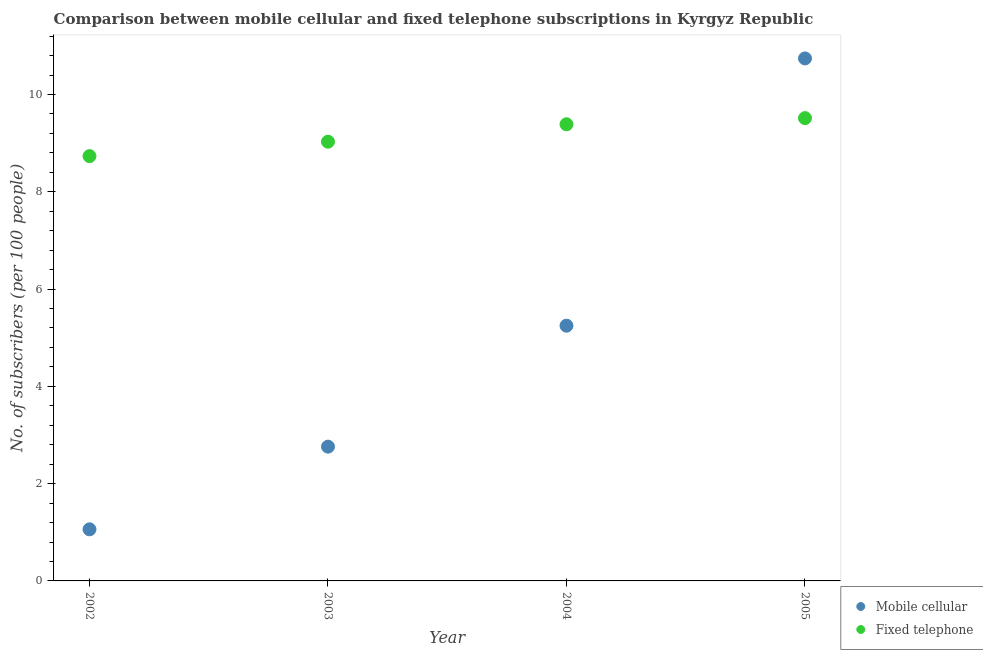Is the number of dotlines equal to the number of legend labels?
Ensure brevity in your answer.  Yes. What is the number of mobile cellular subscribers in 2002?
Offer a terse response. 1.06. Across all years, what is the maximum number of fixed telephone subscribers?
Give a very brief answer. 9.51. Across all years, what is the minimum number of mobile cellular subscribers?
Your response must be concise. 1.06. In which year was the number of fixed telephone subscribers maximum?
Offer a terse response. 2005. What is the total number of mobile cellular subscribers in the graph?
Make the answer very short. 19.81. What is the difference between the number of fixed telephone subscribers in 2002 and that in 2005?
Offer a very short reply. -0.78. What is the difference between the number of fixed telephone subscribers in 2003 and the number of mobile cellular subscribers in 2004?
Your answer should be very brief. 3.78. What is the average number of fixed telephone subscribers per year?
Offer a very short reply. 9.17. In the year 2003, what is the difference between the number of mobile cellular subscribers and number of fixed telephone subscribers?
Your response must be concise. -6.27. What is the ratio of the number of fixed telephone subscribers in 2002 to that in 2003?
Ensure brevity in your answer.  0.97. What is the difference between the highest and the second highest number of fixed telephone subscribers?
Keep it short and to the point. 0.13. What is the difference between the highest and the lowest number of fixed telephone subscribers?
Ensure brevity in your answer.  0.78. In how many years, is the number of mobile cellular subscribers greater than the average number of mobile cellular subscribers taken over all years?
Provide a short and direct response. 2. Is the number of mobile cellular subscribers strictly less than the number of fixed telephone subscribers over the years?
Offer a terse response. No. How many dotlines are there?
Your answer should be compact. 2. How many years are there in the graph?
Make the answer very short. 4. Are the values on the major ticks of Y-axis written in scientific E-notation?
Ensure brevity in your answer.  No. Does the graph contain any zero values?
Provide a short and direct response. No. How are the legend labels stacked?
Ensure brevity in your answer.  Vertical. What is the title of the graph?
Your answer should be compact. Comparison between mobile cellular and fixed telephone subscriptions in Kyrgyz Republic. What is the label or title of the X-axis?
Your answer should be compact. Year. What is the label or title of the Y-axis?
Your answer should be compact. No. of subscribers (per 100 people). What is the No. of subscribers (per 100 people) of Mobile cellular in 2002?
Offer a very short reply. 1.06. What is the No. of subscribers (per 100 people) in Fixed telephone in 2002?
Ensure brevity in your answer.  8.73. What is the No. of subscribers (per 100 people) of Mobile cellular in 2003?
Your answer should be compact. 2.76. What is the No. of subscribers (per 100 people) of Fixed telephone in 2003?
Keep it short and to the point. 9.03. What is the No. of subscribers (per 100 people) of Mobile cellular in 2004?
Provide a short and direct response. 5.25. What is the No. of subscribers (per 100 people) of Fixed telephone in 2004?
Give a very brief answer. 9.39. What is the No. of subscribers (per 100 people) of Mobile cellular in 2005?
Offer a very short reply. 10.74. What is the No. of subscribers (per 100 people) of Fixed telephone in 2005?
Provide a succinct answer. 9.51. Across all years, what is the maximum No. of subscribers (per 100 people) of Mobile cellular?
Give a very brief answer. 10.74. Across all years, what is the maximum No. of subscribers (per 100 people) in Fixed telephone?
Offer a very short reply. 9.51. Across all years, what is the minimum No. of subscribers (per 100 people) of Mobile cellular?
Offer a terse response. 1.06. Across all years, what is the minimum No. of subscribers (per 100 people) in Fixed telephone?
Ensure brevity in your answer.  8.73. What is the total No. of subscribers (per 100 people) in Mobile cellular in the graph?
Ensure brevity in your answer.  19.81. What is the total No. of subscribers (per 100 people) of Fixed telephone in the graph?
Your answer should be very brief. 36.67. What is the difference between the No. of subscribers (per 100 people) of Mobile cellular in 2002 and that in 2003?
Keep it short and to the point. -1.7. What is the difference between the No. of subscribers (per 100 people) in Fixed telephone in 2002 and that in 2003?
Give a very brief answer. -0.3. What is the difference between the No. of subscribers (per 100 people) in Mobile cellular in 2002 and that in 2004?
Your answer should be compact. -4.19. What is the difference between the No. of subscribers (per 100 people) of Fixed telephone in 2002 and that in 2004?
Your response must be concise. -0.65. What is the difference between the No. of subscribers (per 100 people) of Mobile cellular in 2002 and that in 2005?
Give a very brief answer. -9.68. What is the difference between the No. of subscribers (per 100 people) in Fixed telephone in 2002 and that in 2005?
Offer a terse response. -0.78. What is the difference between the No. of subscribers (per 100 people) in Mobile cellular in 2003 and that in 2004?
Provide a short and direct response. -2.49. What is the difference between the No. of subscribers (per 100 people) of Fixed telephone in 2003 and that in 2004?
Ensure brevity in your answer.  -0.36. What is the difference between the No. of subscribers (per 100 people) in Mobile cellular in 2003 and that in 2005?
Make the answer very short. -7.98. What is the difference between the No. of subscribers (per 100 people) of Fixed telephone in 2003 and that in 2005?
Offer a terse response. -0.48. What is the difference between the No. of subscribers (per 100 people) of Mobile cellular in 2004 and that in 2005?
Offer a terse response. -5.49. What is the difference between the No. of subscribers (per 100 people) in Fixed telephone in 2004 and that in 2005?
Your answer should be compact. -0.13. What is the difference between the No. of subscribers (per 100 people) of Mobile cellular in 2002 and the No. of subscribers (per 100 people) of Fixed telephone in 2003?
Your response must be concise. -7.97. What is the difference between the No. of subscribers (per 100 people) in Mobile cellular in 2002 and the No. of subscribers (per 100 people) in Fixed telephone in 2004?
Ensure brevity in your answer.  -8.33. What is the difference between the No. of subscribers (per 100 people) of Mobile cellular in 2002 and the No. of subscribers (per 100 people) of Fixed telephone in 2005?
Ensure brevity in your answer.  -8.45. What is the difference between the No. of subscribers (per 100 people) in Mobile cellular in 2003 and the No. of subscribers (per 100 people) in Fixed telephone in 2004?
Give a very brief answer. -6.63. What is the difference between the No. of subscribers (per 100 people) of Mobile cellular in 2003 and the No. of subscribers (per 100 people) of Fixed telephone in 2005?
Make the answer very short. -6.75. What is the difference between the No. of subscribers (per 100 people) of Mobile cellular in 2004 and the No. of subscribers (per 100 people) of Fixed telephone in 2005?
Your response must be concise. -4.27. What is the average No. of subscribers (per 100 people) of Mobile cellular per year?
Your answer should be very brief. 4.95. What is the average No. of subscribers (per 100 people) in Fixed telephone per year?
Offer a very short reply. 9.17. In the year 2002, what is the difference between the No. of subscribers (per 100 people) of Mobile cellular and No. of subscribers (per 100 people) of Fixed telephone?
Your answer should be very brief. -7.67. In the year 2003, what is the difference between the No. of subscribers (per 100 people) in Mobile cellular and No. of subscribers (per 100 people) in Fixed telephone?
Keep it short and to the point. -6.27. In the year 2004, what is the difference between the No. of subscribers (per 100 people) in Mobile cellular and No. of subscribers (per 100 people) in Fixed telephone?
Your answer should be compact. -4.14. In the year 2005, what is the difference between the No. of subscribers (per 100 people) in Mobile cellular and No. of subscribers (per 100 people) in Fixed telephone?
Give a very brief answer. 1.23. What is the ratio of the No. of subscribers (per 100 people) of Mobile cellular in 2002 to that in 2003?
Provide a succinct answer. 0.38. What is the ratio of the No. of subscribers (per 100 people) of Fixed telephone in 2002 to that in 2003?
Your response must be concise. 0.97. What is the ratio of the No. of subscribers (per 100 people) of Mobile cellular in 2002 to that in 2004?
Provide a short and direct response. 0.2. What is the ratio of the No. of subscribers (per 100 people) of Fixed telephone in 2002 to that in 2004?
Give a very brief answer. 0.93. What is the ratio of the No. of subscribers (per 100 people) in Mobile cellular in 2002 to that in 2005?
Your response must be concise. 0.1. What is the ratio of the No. of subscribers (per 100 people) of Fixed telephone in 2002 to that in 2005?
Your response must be concise. 0.92. What is the ratio of the No. of subscribers (per 100 people) of Mobile cellular in 2003 to that in 2004?
Your response must be concise. 0.53. What is the ratio of the No. of subscribers (per 100 people) of Fixed telephone in 2003 to that in 2004?
Keep it short and to the point. 0.96. What is the ratio of the No. of subscribers (per 100 people) of Mobile cellular in 2003 to that in 2005?
Ensure brevity in your answer.  0.26. What is the ratio of the No. of subscribers (per 100 people) of Fixed telephone in 2003 to that in 2005?
Keep it short and to the point. 0.95. What is the ratio of the No. of subscribers (per 100 people) of Mobile cellular in 2004 to that in 2005?
Make the answer very short. 0.49. What is the ratio of the No. of subscribers (per 100 people) in Fixed telephone in 2004 to that in 2005?
Provide a succinct answer. 0.99. What is the difference between the highest and the second highest No. of subscribers (per 100 people) of Mobile cellular?
Give a very brief answer. 5.49. What is the difference between the highest and the second highest No. of subscribers (per 100 people) in Fixed telephone?
Make the answer very short. 0.13. What is the difference between the highest and the lowest No. of subscribers (per 100 people) of Mobile cellular?
Provide a short and direct response. 9.68. What is the difference between the highest and the lowest No. of subscribers (per 100 people) in Fixed telephone?
Your answer should be compact. 0.78. 